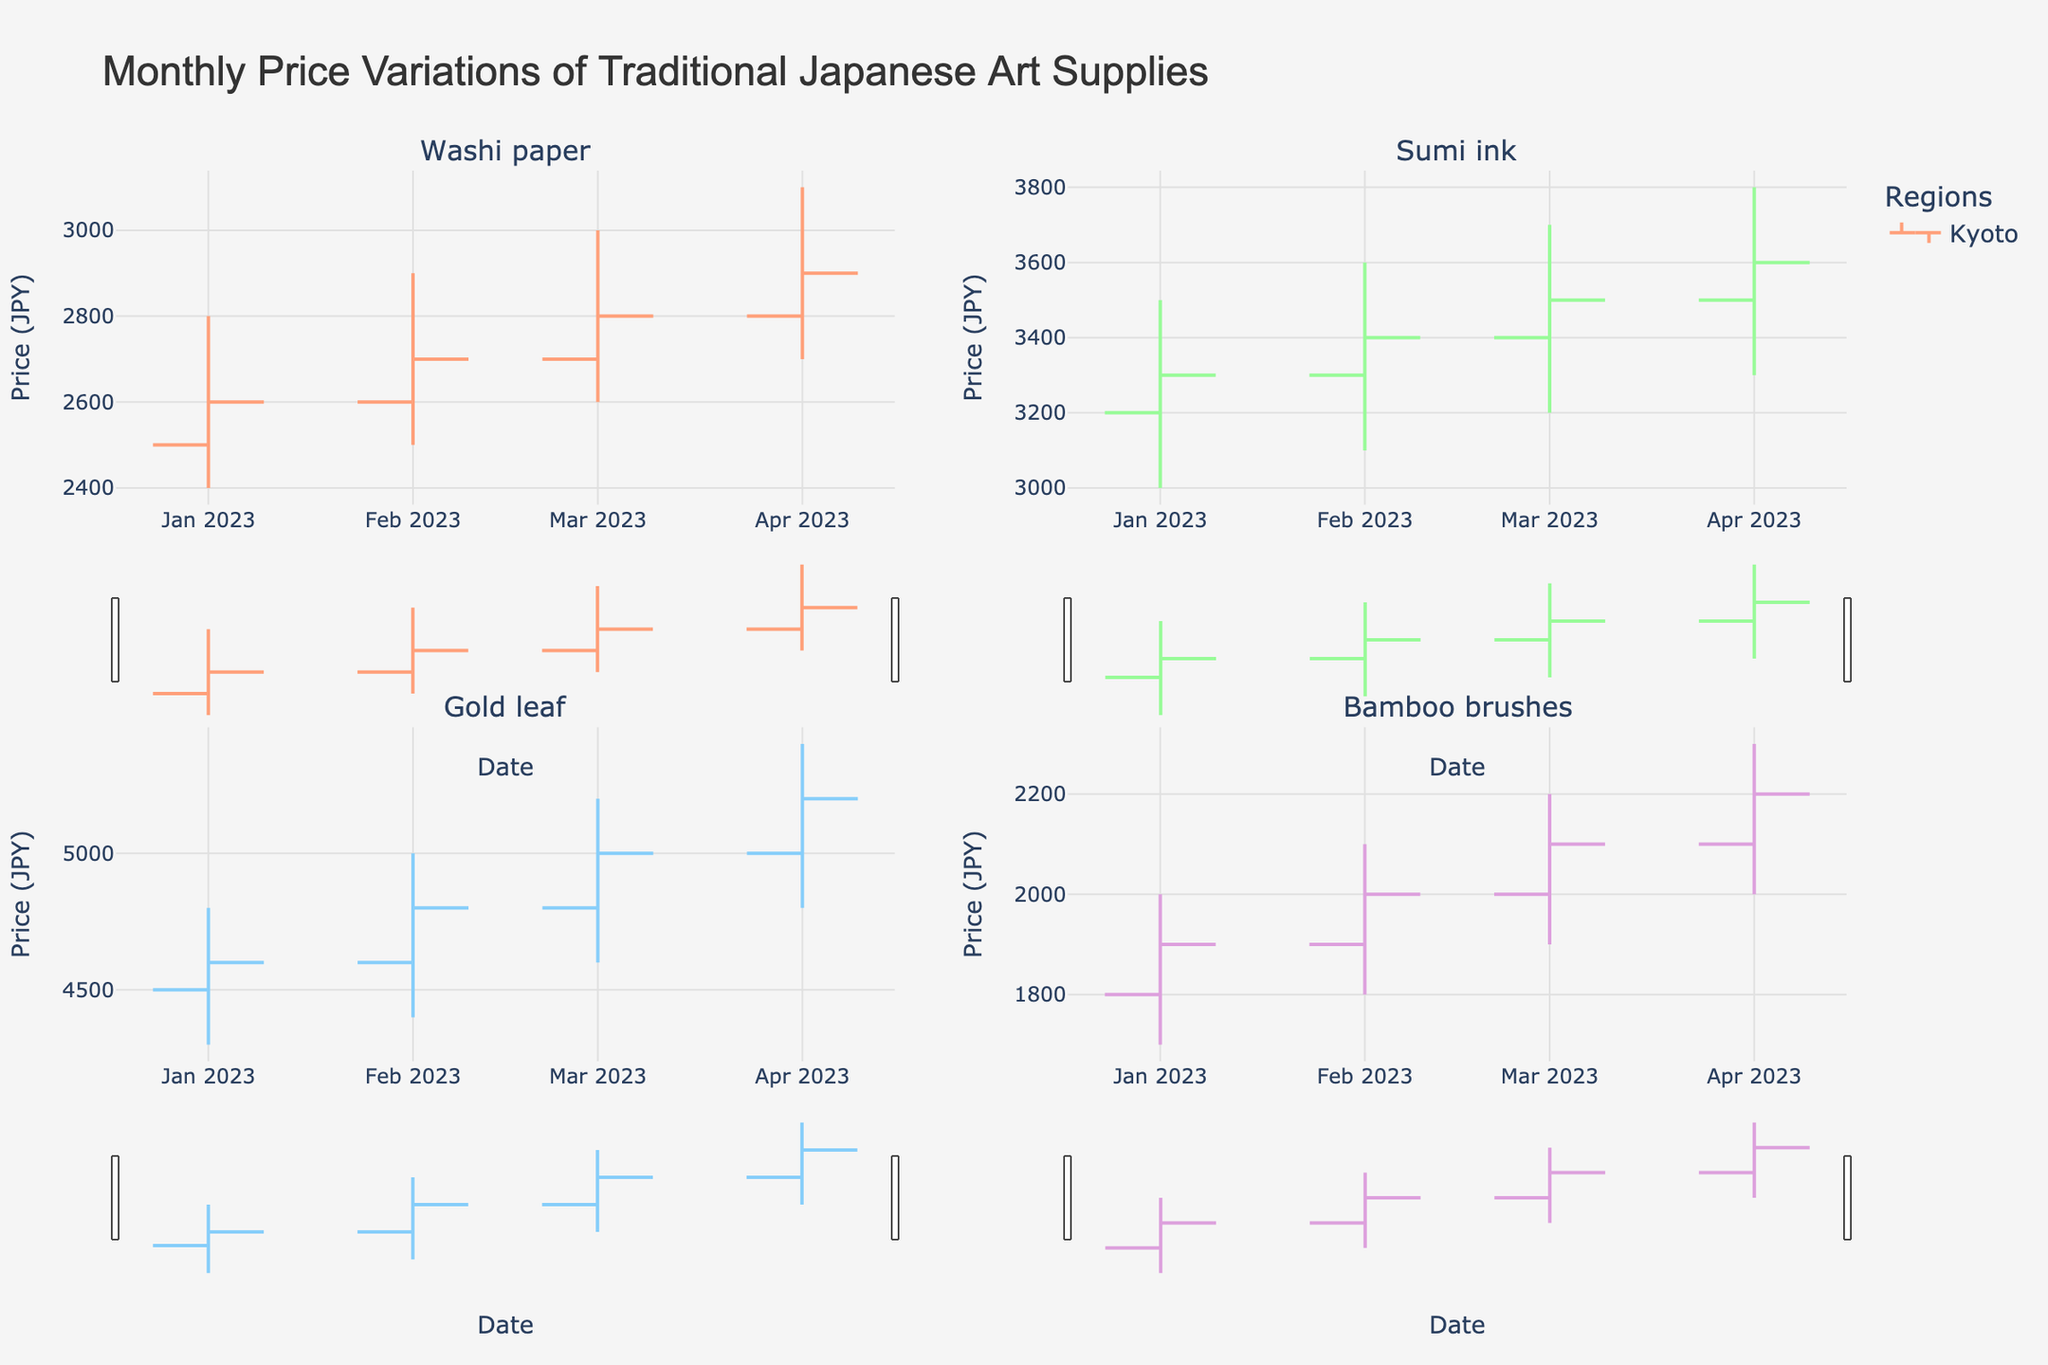What is the title of the figure? The title is located at the top-center of the figure and provides a summary of the chart being displayed.
Answer: Monthly Price Variations of Traditional Japanese Art Supplies Which region showed an increase in the price of 'Washi paper' between February and March 2023? By comparing the closing prices of 'Washi paper' in Kyoto from February (2700 JPY) and March (2800 JPY), we see that the price increased.
Answer: Kyoto What was the highest price recorded for 'Gold leaf' in Kanazawa during the observed months? The highest price is indicated by the top of the wick on the OHLC bars. For Kanazawa, the highest price for 'Gold leaf' is recorded in April (5400 JPY).
Answer: 5400 JPY Which traditional supply had the most stable price in Nara over the observed period? By observing the OHLC bars for Nara, the most stable supply would have the smallest range between high and low prices. 'Bamboo brushes' in Nara shows relatively small variations each month.
Answer: Bamboo brushes How did the price of 'Sumi ink' in Tokyo change from March to April 2023? Observing the closing prices for 'Sumi ink' in Tokyo between March (3500 JPY) and April (3600 JPY), the price increased.
Answer: Increased What is the largest price difference between the high and low prices for 'Bamboo brushes' in Nara? By examining the OHLC bars, the largest difference is observed in April, with high (2300) - low (2000) = 300 JPY.
Answer: 300 JPY In which month did 'Gold leaf' in Kanazawa have the lowest closing price? The closing prices for 'Gold leaf' in Kanazawa are compared across months. The lowest closing price is in January (4600 JPY).
Answer: January 2023 Among all the traditional supplies, which one experienced the largest increase in the opening price from January to April in Kyoto? Comparing the opening prices from January to April for all supplies in Kyoto, 'Washi paper' increased from 2500 to 2800 JPY (300 JPY increase).
Answer: Washi paper Which region has a different color representation than Kyoto in the OHLC chart? By examining the colors used for different regions, Tokyo, Kanazawa, and Nara have different colors from Kyoto.
Answer: Tokyo, Kanazawa, Nara What is the average closing price of 'Washi paper' in Kyoto over the observed months? Summing the closing prices of 'Washi paper' in Kyoto over the 4 months and dividing by 4: (2600 + 2700 + 2800 + 2900) / 4 = 2750 JPY.
Answer: 2750 JPY 